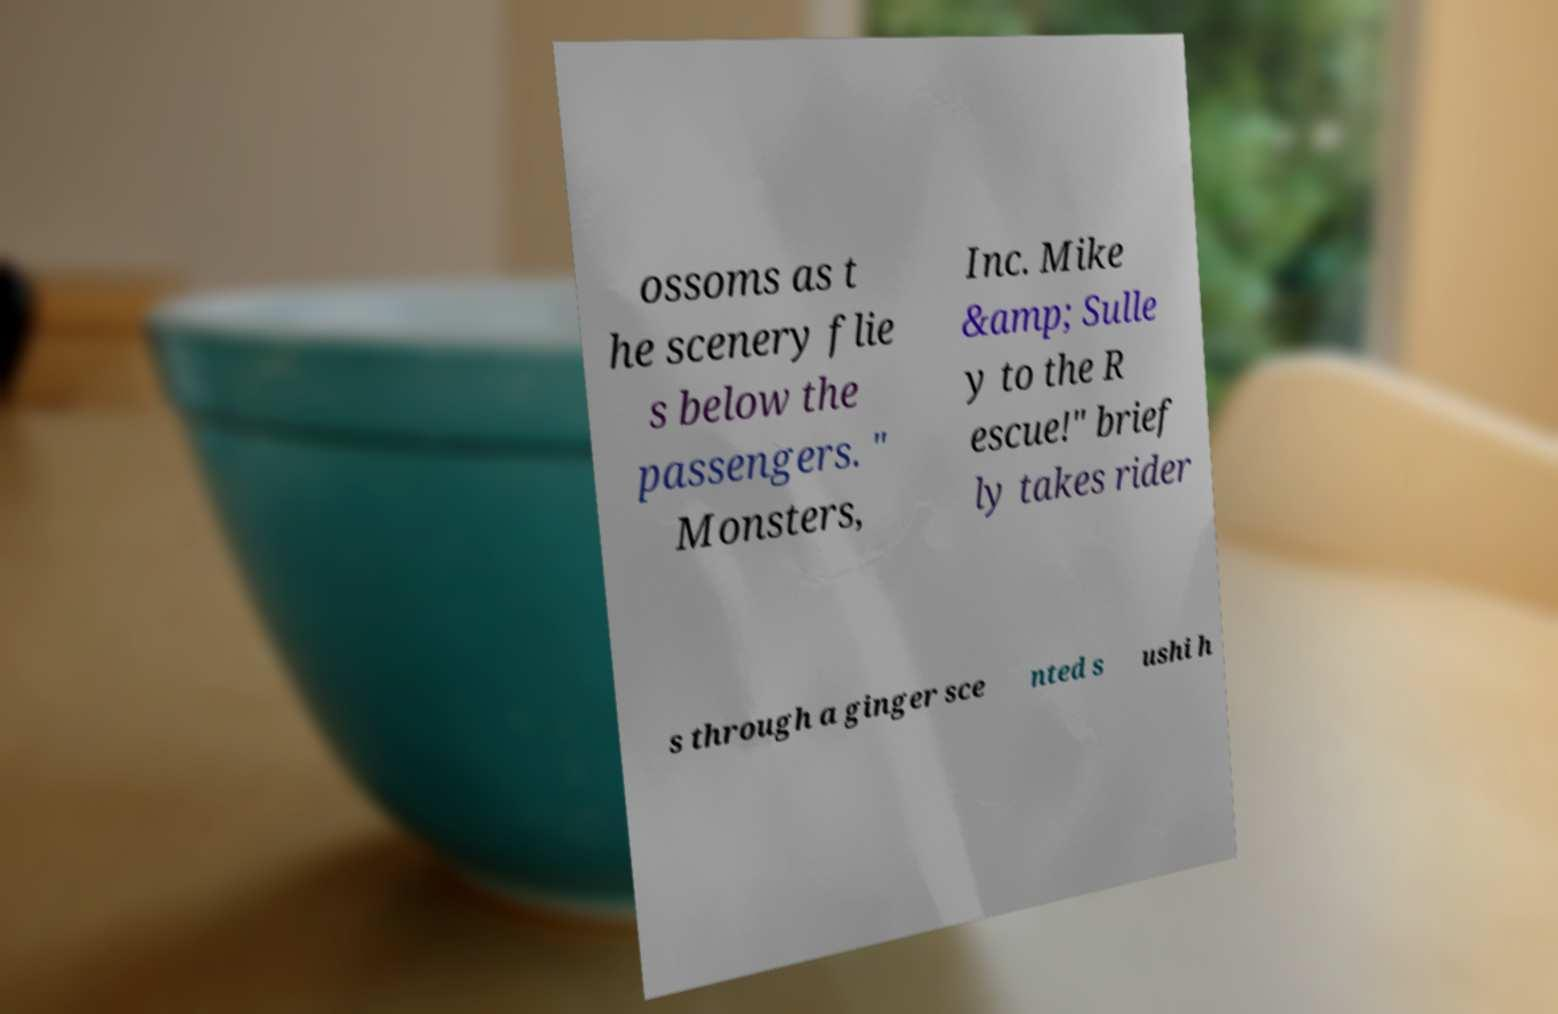Please identify and transcribe the text found in this image. ossoms as t he scenery flie s below the passengers. " Monsters, Inc. Mike &amp; Sulle y to the R escue!" brief ly takes rider s through a ginger sce nted s ushi h 